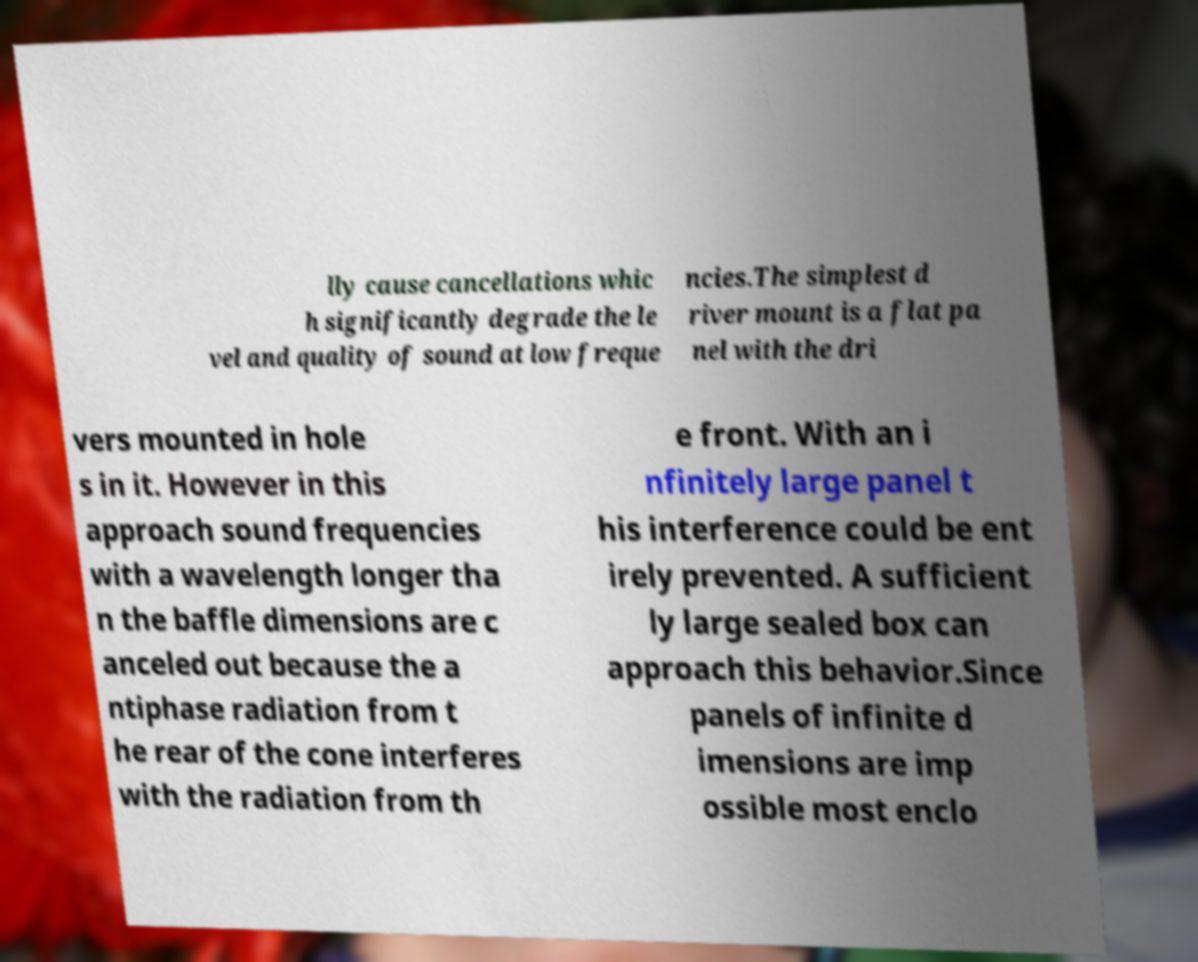Could you extract and type out the text from this image? lly cause cancellations whic h significantly degrade the le vel and quality of sound at low freque ncies.The simplest d river mount is a flat pa nel with the dri vers mounted in hole s in it. However in this approach sound frequencies with a wavelength longer tha n the baffle dimensions are c anceled out because the a ntiphase radiation from t he rear of the cone interferes with the radiation from th e front. With an i nfinitely large panel t his interference could be ent irely prevented. A sufficient ly large sealed box can approach this behavior.Since panels of infinite d imensions are imp ossible most enclo 